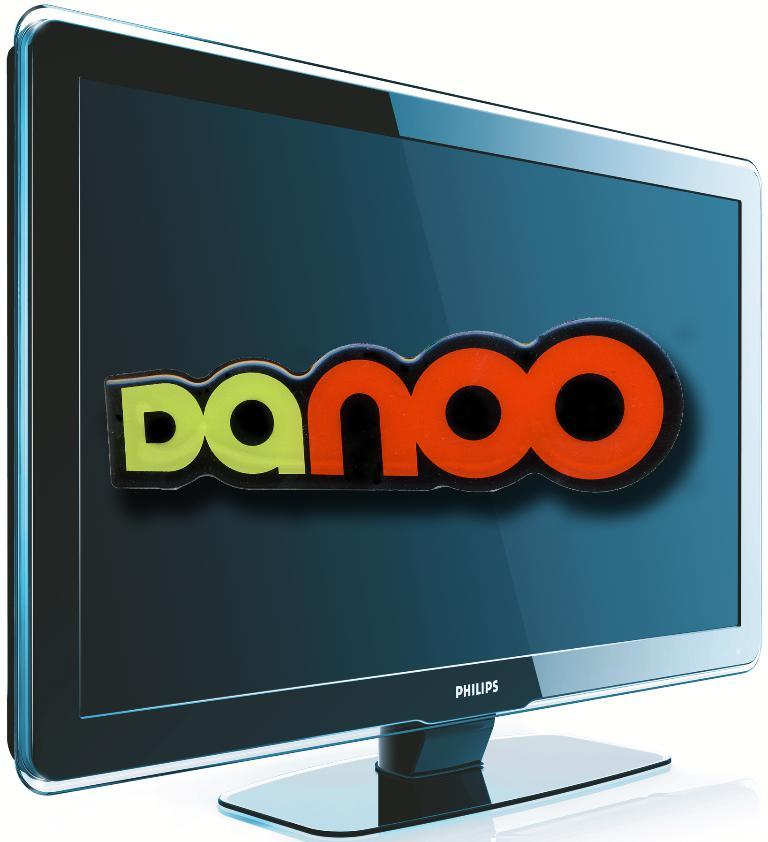Provide a one-sentence caption for the provided image. Computer monitor by Philips that says "Danoo" on it. 